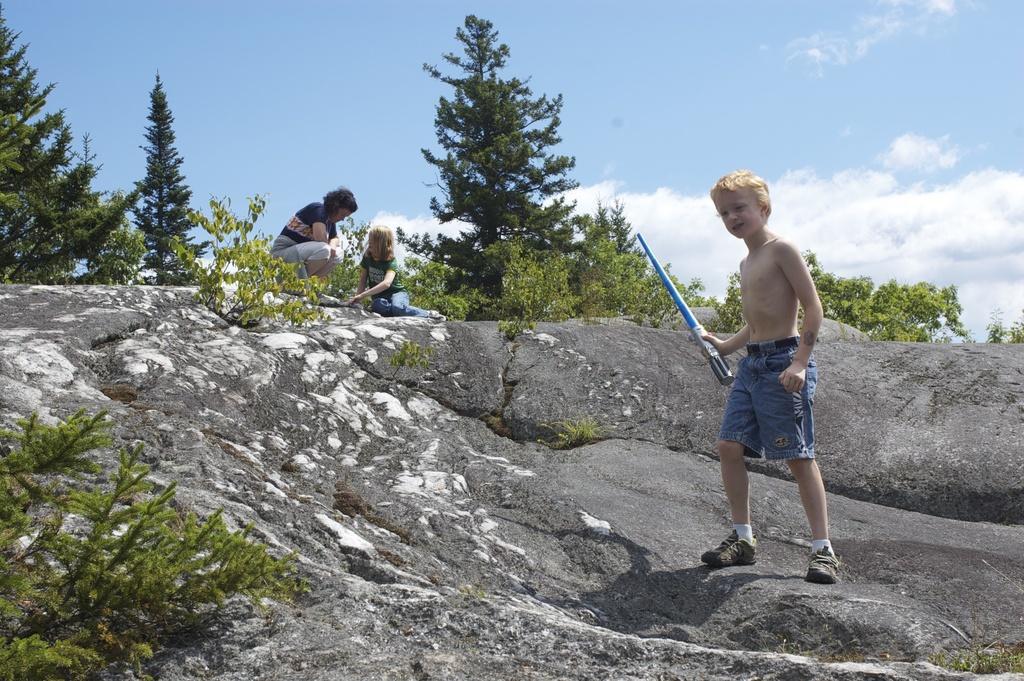How would you summarize this image in a sentence or two? In this image there is a women and two kids, one kid is holding a stick in his hand and standing on a rock in the background there are trees and a sky. 